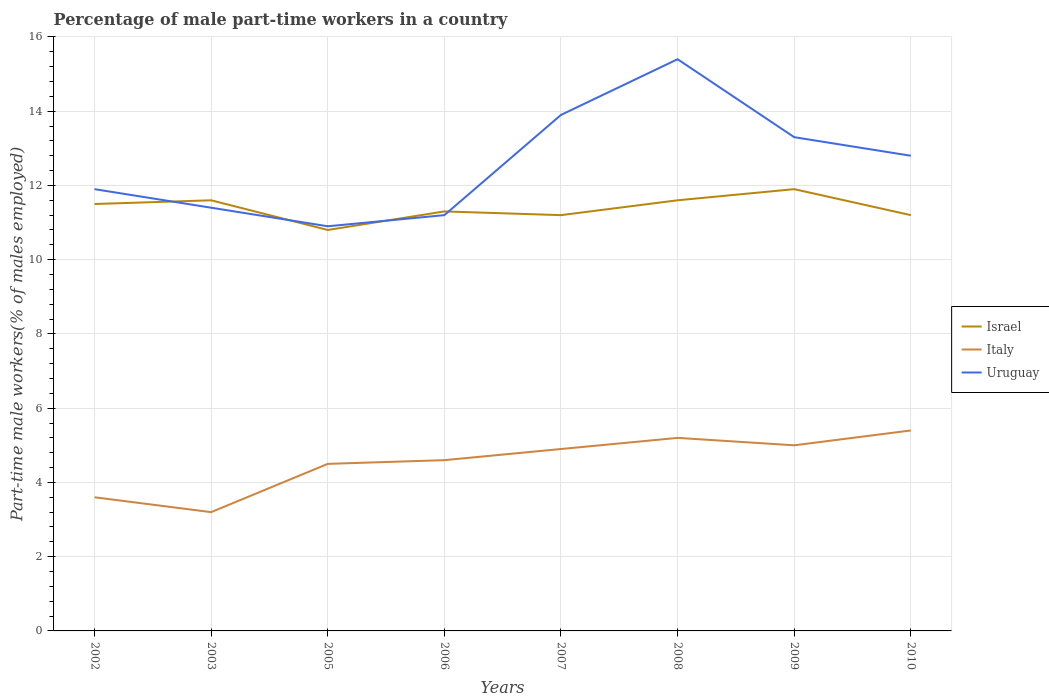Is the number of lines equal to the number of legend labels?
Keep it short and to the point. Yes. Across all years, what is the maximum percentage of male part-time workers in Uruguay?
Your response must be concise. 10.9. In which year was the percentage of male part-time workers in Italy maximum?
Your answer should be very brief. 2003. What is the difference between the highest and the second highest percentage of male part-time workers in Italy?
Your answer should be very brief. 2.2. Is the percentage of male part-time workers in Italy strictly greater than the percentage of male part-time workers in Israel over the years?
Provide a short and direct response. Yes. How many lines are there?
Provide a succinct answer. 3. How many years are there in the graph?
Offer a terse response. 8. What is the difference between two consecutive major ticks on the Y-axis?
Your answer should be compact. 2. Are the values on the major ticks of Y-axis written in scientific E-notation?
Your response must be concise. No. Does the graph contain grids?
Your answer should be very brief. Yes. How are the legend labels stacked?
Offer a very short reply. Vertical. What is the title of the graph?
Keep it short and to the point. Percentage of male part-time workers in a country. Does "Zimbabwe" appear as one of the legend labels in the graph?
Make the answer very short. No. What is the label or title of the Y-axis?
Keep it short and to the point. Part-time male workers(% of males employed). What is the Part-time male workers(% of males employed) of Israel in 2002?
Make the answer very short. 11.5. What is the Part-time male workers(% of males employed) in Italy in 2002?
Provide a succinct answer. 3.6. What is the Part-time male workers(% of males employed) of Uruguay in 2002?
Provide a short and direct response. 11.9. What is the Part-time male workers(% of males employed) of Israel in 2003?
Provide a succinct answer. 11.6. What is the Part-time male workers(% of males employed) in Italy in 2003?
Offer a terse response. 3.2. What is the Part-time male workers(% of males employed) of Uruguay in 2003?
Your answer should be compact. 11.4. What is the Part-time male workers(% of males employed) of Israel in 2005?
Your answer should be very brief. 10.8. What is the Part-time male workers(% of males employed) in Italy in 2005?
Give a very brief answer. 4.5. What is the Part-time male workers(% of males employed) in Uruguay in 2005?
Offer a terse response. 10.9. What is the Part-time male workers(% of males employed) of Israel in 2006?
Your response must be concise. 11.3. What is the Part-time male workers(% of males employed) of Italy in 2006?
Offer a terse response. 4.6. What is the Part-time male workers(% of males employed) in Uruguay in 2006?
Your response must be concise. 11.2. What is the Part-time male workers(% of males employed) in Israel in 2007?
Give a very brief answer. 11.2. What is the Part-time male workers(% of males employed) of Italy in 2007?
Offer a terse response. 4.9. What is the Part-time male workers(% of males employed) in Uruguay in 2007?
Your answer should be compact. 13.9. What is the Part-time male workers(% of males employed) of Israel in 2008?
Your response must be concise. 11.6. What is the Part-time male workers(% of males employed) in Italy in 2008?
Keep it short and to the point. 5.2. What is the Part-time male workers(% of males employed) in Uruguay in 2008?
Keep it short and to the point. 15.4. What is the Part-time male workers(% of males employed) of Israel in 2009?
Offer a terse response. 11.9. What is the Part-time male workers(% of males employed) in Uruguay in 2009?
Offer a terse response. 13.3. What is the Part-time male workers(% of males employed) in Israel in 2010?
Your answer should be compact. 11.2. What is the Part-time male workers(% of males employed) in Italy in 2010?
Make the answer very short. 5.4. What is the Part-time male workers(% of males employed) in Uruguay in 2010?
Offer a terse response. 12.8. Across all years, what is the maximum Part-time male workers(% of males employed) of Israel?
Offer a very short reply. 11.9. Across all years, what is the maximum Part-time male workers(% of males employed) of Italy?
Keep it short and to the point. 5.4. Across all years, what is the maximum Part-time male workers(% of males employed) of Uruguay?
Your answer should be compact. 15.4. Across all years, what is the minimum Part-time male workers(% of males employed) in Israel?
Offer a very short reply. 10.8. Across all years, what is the minimum Part-time male workers(% of males employed) of Italy?
Give a very brief answer. 3.2. Across all years, what is the minimum Part-time male workers(% of males employed) of Uruguay?
Provide a succinct answer. 10.9. What is the total Part-time male workers(% of males employed) in Israel in the graph?
Give a very brief answer. 91.1. What is the total Part-time male workers(% of males employed) of Italy in the graph?
Offer a terse response. 36.4. What is the total Part-time male workers(% of males employed) of Uruguay in the graph?
Your answer should be very brief. 100.8. What is the difference between the Part-time male workers(% of males employed) in Israel in 2002 and that in 2003?
Keep it short and to the point. -0.1. What is the difference between the Part-time male workers(% of males employed) in Italy in 2002 and that in 2003?
Keep it short and to the point. 0.4. What is the difference between the Part-time male workers(% of males employed) in Uruguay in 2002 and that in 2003?
Your answer should be very brief. 0.5. What is the difference between the Part-time male workers(% of males employed) of Israel in 2002 and that in 2005?
Keep it short and to the point. 0.7. What is the difference between the Part-time male workers(% of males employed) of Uruguay in 2002 and that in 2005?
Offer a terse response. 1. What is the difference between the Part-time male workers(% of males employed) in Uruguay in 2002 and that in 2006?
Offer a very short reply. 0.7. What is the difference between the Part-time male workers(% of males employed) in Italy in 2002 and that in 2007?
Keep it short and to the point. -1.3. What is the difference between the Part-time male workers(% of males employed) of Uruguay in 2002 and that in 2008?
Make the answer very short. -3.5. What is the difference between the Part-time male workers(% of males employed) in Israel in 2002 and that in 2009?
Your response must be concise. -0.4. What is the difference between the Part-time male workers(% of males employed) in Uruguay in 2002 and that in 2009?
Your answer should be very brief. -1.4. What is the difference between the Part-time male workers(% of males employed) in Israel in 2003 and that in 2005?
Ensure brevity in your answer.  0.8. What is the difference between the Part-time male workers(% of males employed) in Uruguay in 2003 and that in 2005?
Your response must be concise. 0.5. What is the difference between the Part-time male workers(% of males employed) of Israel in 2003 and that in 2006?
Ensure brevity in your answer.  0.3. What is the difference between the Part-time male workers(% of males employed) in Italy in 2003 and that in 2006?
Your response must be concise. -1.4. What is the difference between the Part-time male workers(% of males employed) in Uruguay in 2003 and that in 2006?
Make the answer very short. 0.2. What is the difference between the Part-time male workers(% of males employed) of Italy in 2003 and that in 2009?
Provide a short and direct response. -1.8. What is the difference between the Part-time male workers(% of males employed) of Italy in 2003 and that in 2010?
Keep it short and to the point. -2.2. What is the difference between the Part-time male workers(% of males employed) of Israel in 2005 and that in 2006?
Ensure brevity in your answer.  -0.5. What is the difference between the Part-time male workers(% of males employed) of Israel in 2005 and that in 2007?
Offer a terse response. -0.4. What is the difference between the Part-time male workers(% of males employed) in Italy in 2005 and that in 2008?
Provide a succinct answer. -0.7. What is the difference between the Part-time male workers(% of males employed) in Israel in 2005 and that in 2009?
Give a very brief answer. -1.1. What is the difference between the Part-time male workers(% of males employed) of Italy in 2005 and that in 2009?
Ensure brevity in your answer.  -0.5. What is the difference between the Part-time male workers(% of males employed) in Israel in 2005 and that in 2010?
Provide a short and direct response. -0.4. What is the difference between the Part-time male workers(% of males employed) of Italy in 2005 and that in 2010?
Provide a succinct answer. -0.9. What is the difference between the Part-time male workers(% of males employed) in Uruguay in 2005 and that in 2010?
Offer a terse response. -1.9. What is the difference between the Part-time male workers(% of males employed) in Israel in 2006 and that in 2007?
Give a very brief answer. 0.1. What is the difference between the Part-time male workers(% of males employed) of Israel in 2006 and that in 2008?
Your answer should be very brief. -0.3. What is the difference between the Part-time male workers(% of males employed) in Uruguay in 2006 and that in 2009?
Keep it short and to the point. -2.1. What is the difference between the Part-time male workers(% of males employed) in Israel in 2006 and that in 2010?
Offer a very short reply. 0.1. What is the difference between the Part-time male workers(% of males employed) of Italy in 2007 and that in 2008?
Provide a succinct answer. -0.3. What is the difference between the Part-time male workers(% of males employed) of Israel in 2007 and that in 2009?
Your answer should be very brief. -0.7. What is the difference between the Part-time male workers(% of males employed) of Uruguay in 2007 and that in 2010?
Keep it short and to the point. 1.1. What is the difference between the Part-time male workers(% of males employed) in Israel in 2008 and that in 2009?
Your answer should be very brief. -0.3. What is the difference between the Part-time male workers(% of males employed) in Italy in 2008 and that in 2009?
Your answer should be compact. 0.2. What is the difference between the Part-time male workers(% of males employed) in Israel in 2008 and that in 2010?
Offer a very short reply. 0.4. What is the difference between the Part-time male workers(% of males employed) in Uruguay in 2008 and that in 2010?
Keep it short and to the point. 2.6. What is the difference between the Part-time male workers(% of males employed) in Israel in 2009 and that in 2010?
Your answer should be very brief. 0.7. What is the difference between the Part-time male workers(% of males employed) in Italy in 2009 and that in 2010?
Your answer should be very brief. -0.4. What is the difference between the Part-time male workers(% of males employed) in Israel in 2002 and the Part-time male workers(% of males employed) in Uruguay in 2003?
Ensure brevity in your answer.  0.1. What is the difference between the Part-time male workers(% of males employed) of Italy in 2002 and the Part-time male workers(% of males employed) of Uruguay in 2003?
Make the answer very short. -7.8. What is the difference between the Part-time male workers(% of males employed) in Israel in 2002 and the Part-time male workers(% of males employed) in Italy in 2005?
Provide a short and direct response. 7. What is the difference between the Part-time male workers(% of males employed) of Israel in 2002 and the Part-time male workers(% of males employed) of Italy in 2006?
Ensure brevity in your answer.  6.9. What is the difference between the Part-time male workers(% of males employed) in Israel in 2002 and the Part-time male workers(% of males employed) in Uruguay in 2006?
Offer a terse response. 0.3. What is the difference between the Part-time male workers(% of males employed) in Italy in 2002 and the Part-time male workers(% of males employed) in Uruguay in 2006?
Offer a very short reply. -7.6. What is the difference between the Part-time male workers(% of males employed) of Israel in 2002 and the Part-time male workers(% of males employed) of Italy in 2007?
Provide a short and direct response. 6.6. What is the difference between the Part-time male workers(% of males employed) of Israel in 2002 and the Part-time male workers(% of males employed) of Uruguay in 2007?
Provide a short and direct response. -2.4. What is the difference between the Part-time male workers(% of males employed) of Italy in 2002 and the Part-time male workers(% of males employed) of Uruguay in 2007?
Offer a terse response. -10.3. What is the difference between the Part-time male workers(% of males employed) in Israel in 2002 and the Part-time male workers(% of males employed) in Italy in 2008?
Your answer should be very brief. 6.3. What is the difference between the Part-time male workers(% of males employed) of Israel in 2002 and the Part-time male workers(% of males employed) of Uruguay in 2008?
Provide a succinct answer. -3.9. What is the difference between the Part-time male workers(% of males employed) in Italy in 2002 and the Part-time male workers(% of males employed) in Uruguay in 2008?
Your answer should be compact. -11.8. What is the difference between the Part-time male workers(% of males employed) of Italy in 2002 and the Part-time male workers(% of males employed) of Uruguay in 2009?
Offer a very short reply. -9.7. What is the difference between the Part-time male workers(% of males employed) of Italy in 2002 and the Part-time male workers(% of males employed) of Uruguay in 2010?
Offer a very short reply. -9.2. What is the difference between the Part-time male workers(% of males employed) in Israel in 2003 and the Part-time male workers(% of males employed) in Uruguay in 2006?
Your response must be concise. 0.4. What is the difference between the Part-time male workers(% of males employed) in Italy in 2003 and the Part-time male workers(% of males employed) in Uruguay in 2006?
Offer a terse response. -8. What is the difference between the Part-time male workers(% of males employed) in Israel in 2003 and the Part-time male workers(% of males employed) in Uruguay in 2007?
Offer a terse response. -2.3. What is the difference between the Part-time male workers(% of males employed) in Italy in 2003 and the Part-time male workers(% of males employed) in Uruguay in 2007?
Make the answer very short. -10.7. What is the difference between the Part-time male workers(% of males employed) in Israel in 2003 and the Part-time male workers(% of males employed) in Italy in 2008?
Provide a succinct answer. 6.4. What is the difference between the Part-time male workers(% of males employed) of Israel in 2003 and the Part-time male workers(% of males employed) of Italy in 2009?
Provide a succinct answer. 6.6. What is the difference between the Part-time male workers(% of males employed) in Israel in 2003 and the Part-time male workers(% of males employed) in Uruguay in 2009?
Make the answer very short. -1.7. What is the difference between the Part-time male workers(% of males employed) of Israel in 2003 and the Part-time male workers(% of males employed) of Italy in 2010?
Your answer should be very brief. 6.2. What is the difference between the Part-time male workers(% of males employed) in Israel in 2003 and the Part-time male workers(% of males employed) in Uruguay in 2010?
Your answer should be very brief. -1.2. What is the difference between the Part-time male workers(% of males employed) of Israel in 2005 and the Part-time male workers(% of males employed) of Italy in 2006?
Offer a very short reply. 6.2. What is the difference between the Part-time male workers(% of males employed) in Israel in 2005 and the Part-time male workers(% of males employed) in Uruguay in 2006?
Provide a short and direct response. -0.4. What is the difference between the Part-time male workers(% of males employed) in Italy in 2005 and the Part-time male workers(% of males employed) in Uruguay in 2006?
Ensure brevity in your answer.  -6.7. What is the difference between the Part-time male workers(% of males employed) in Israel in 2005 and the Part-time male workers(% of males employed) in Italy in 2008?
Your response must be concise. 5.6. What is the difference between the Part-time male workers(% of males employed) of Italy in 2005 and the Part-time male workers(% of males employed) of Uruguay in 2008?
Provide a short and direct response. -10.9. What is the difference between the Part-time male workers(% of males employed) of Israel in 2005 and the Part-time male workers(% of males employed) of Italy in 2009?
Your answer should be compact. 5.8. What is the difference between the Part-time male workers(% of males employed) in Italy in 2005 and the Part-time male workers(% of males employed) in Uruguay in 2009?
Provide a succinct answer. -8.8. What is the difference between the Part-time male workers(% of males employed) of Israel in 2005 and the Part-time male workers(% of males employed) of Italy in 2010?
Make the answer very short. 5.4. What is the difference between the Part-time male workers(% of males employed) in Israel in 2005 and the Part-time male workers(% of males employed) in Uruguay in 2010?
Offer a very short reply. -2. What is the difference between the Part-time male workers(% of males employed) of Italy in 2005 and the Part-time male workers(% of males employed) of Uruguay in 2010?
Provide a succinct answer. -8.3. What is the difference between the Part-time male workers(% of males employed) in Israel in 2006 and the Part-time male workers(% of males employed) in Italy in 2008?
Ensure brevity in your answer.  6.1. What is the difference between the Part-time male workers(% of males employed) of Israel in 2006 and the Part-time male workers(% of males employed) of Uruguay in 2008?
Offer a very short reply. -4.1. What is the difference between the Part-time male workers(% of males employed) of Italy in 2006 and the Part-time male workers(% of males employed) of Uruguay in 2009?
Offer a terse response. -8.7. What is the difference between the Part-time male workers(% of males employed) in Israel in 2007 and the Part-time male workers(% of males employed) in Italy in 2008?
Give a very brief answer. 6. What is the difference between the Part-time male workers(% of males employed) of Israel in 2007 and the Part-time male workers(% of males employed) of Italy in 2009?
Provide a short and direct response. 6.2. What is the difference between the Part-time male workers(% of males employed) in Israel in 2007 and the Part-time male workers(% of males employed) in Uruguay in 2009?
Offer a very short reply. -2.1. What is the difference between the Part-time male workers(% of males employed) in Israel in 2007 and the Part-time male workers(% of males employed) in Italy in 2010?
Keep it short and to the point. 5.8. What is the difference between the Part-time male workers(% of males employed) of Israel in 2008 and the Part-time male workers(% of males employed) of Uruguay in 2009?
Provide a succinct answer. -1.7. What is the difference between the Part-time male workers(% of males employed) of Israel in 2008 and the Part-time male workers(% of males employed) of Italy in 2010?
Make the answer very short. 6.2. What is the difference between the Part-time male workers(% of males employed) in Israel in 2008 and the Part-time male workers(% of males employed) in Uruguay in 2010?
Ensure brevity in your answer.  -1.2. What is the difference between the Part-time male workers(% of males employed) of Italy in 2008 and the Part-time male workers(% of males employed) of Uruguay in 2010?
Make the answer very short. -7.6. What is the difference between the Part-time male workers(% of males employed) of Israel in 2009 and the Part-time male workers(% of males employed) of Italy in 2010?
Keep it short and to the point. 6.5. What is the difference between the Part-time male workers(% of males employed) of Israel in 2009 and the Part-time male workers(% of males employed) of Uruguay in 2010?
Offer a very short reply. -0.9. What is the average Part-time male workers(% of males employed) of Israel per year?
Keep it short and to the point. 11.39. What is the average Part-time male workers(% of males employed) of Italy per year?
Make the answer very short. 4.55. What is the average Part-time male workers(% of males employed) of Uruguay per year?
Offer a terse response. 12.6. In the year 2002, what is the difference between the Part-time male workers(% of males employed) in Italy and Part-time male workers(% of males employed) in Uruguay?
Give a very brief answer. -8.3. In the year 2005, what is the difference between the Part-time male workers(% of males employed) of Italy and Part-time male workers(% of males employed) of Uruguay?
Your answer should be very brief. -6.4. In the year 2006, what is the difference between the Part-time male workers(% of males employed) in Israel and Part-time male workers(% of males employed) in Italy?
Your answer should be very brief. 6.7. In the year 2006, what is the difference between the Part-time male workers(% of males employed) in Israel and Part-time male workers(% of males employed) in Uruguay?
Ensure brevity in your answer.  0.1. In the year 2006, what is the difference between the Part-time male workers(% of males employed) in Italy and Part-time male workers(% of males employed) in Uruguay?
Ensure brevity in your answer.  -6.6. In the year 2007, what is the difference between the Part-time male workers(% of males employed) in Israel and Part-time male workers(% of males employed) in Italy?
Provide a succinct answer. 6.3. In the year 2008, what is the difference between the Part-time male workers(% of males employed) of Italy and Part-time male workers(% of males employed) of Uruguay?
Make the answer very short. -10.2. In the year 2009, what is the difference between the Part-time male workers(% of males employed) of Israel and Part-time male workers(% of males employed) of Italy?
Provide a short and direct response. 6.9. In the year 2009, what is the difference between the Part-time male workers(% of males employed) in Italy and Part-time male workers(% of males employed) in Uruguay?
Your response must be concise. -8.3. In the year 2010, what is the difference between the Part-time male workers(% of males employed) of Israel and Part-time male workers(% of males employed) of Italy?
Your answer should be very brief. 5.8. In the year 2010, what is the difference between the Part-time male workers(% of males employed) of Italy and Part-time male workers(% of males employed) of Uruguay?
Your answer should be very brief. -7.4. What is the ratio of the Part-time male workers(% of males employed) of Italy in 2002 to that in 2003?
Make the answer very short. 1.12. What is the ratio of the Part-time male workers(% of males employed) in Uruguay in 2002 to that in 2003?
Your answer should be compact. 1.04. What is the ratio of the Part-time male workers(% of males employed) in Israel in 2002 to that in 2005?
Offer a terse response. 1.06. What is the ratio of the Part-time male workers(% of males employed) in Italy in 2002 to that in 2005?
Make the answer very short. 0.8. What is the ratio of the Part-time male workers(% of males employed) in Uruguay in 2002 to that in 2005?
Offer a very short reply. 1.09. What is the ratio of the Part-time male workers(% of males employed) in Israel in 2002 to that in 2006?
Provide a short and direct response. 1.02. What is the ratio of the Part-time male workers(% of males employed) in Italy in 2002 to that in 2006?
Offer a terse response. 0.78. What is the ratio of the Part-time male workers(% of males employed) in Israel in 2002 to that in 2007?
Make the answer very short. 1.03. What is the ratio of the Part-time male workers(% of males employed) of Italy in 2002 to that in 2007?
Keep it short and to the point. 0.73. What is the ratio of the Part-time male workers(% of males employed) of Uruguay in 2002 to that in 2007?
Your response must be concise. 0.86. What is the ratio of the Part-time male workers(% of males employed) of Israel in 2002 to that in 2008?
Offer a terse response. 0.99. What is the ratio of the Part-time male workers(% of males employed) of Italy in 2002 to that in 2008?
Make the answer very short. 0.69. What is the ratio of the Part-time male workers(% of males employed) of Uruguay in 2002 to that in 2008?
Make the answer very short. 0.77. What is the ratio of the Part-time male workers(% of males employed) of Israel in 2002 to that in 2009?
Offer a very short reply. 0.97. What is the ratio of the Part-time male workers(% of males employed) of Italy in 2002 to that in 2009?
Make the answer very short. 0.72. What is the ratio of the Part-time male workers(% of males employed) of Uruguay in 2002 to that in 2009?
Provide a short and direct response. 0.89. What is the ratio of the Part-time male workers(% of males employed) in Israel in 2002 to that in 2010?
Provide a succinct answer. 1.03. What is the ratio of the Part-time male workers(% of males employed) of Uruguay in 2002 to that in 2010?
Your response must be concise. 0.93. What is the ratio of the Part-time male workers(% of males employed) of Israel in 2003 to that in 2005?
Your answer should be compact. 1.07. What is the ratio of the Part-time male workers(% of males employed) in Italy in 2003 to that in 2005?
Make the answer very short. 0.71. What is the ratio of the Part-time male workers(% of males employed) of Uruguay in 2003 to that in 2005?
Provide a short and direct response. 1.05. What is the ratio of the Part-time male workers(% of males employed) of Israel in 2003 to that in 2006?
Your answer should be compact. 1.03. What is the ratio of the Part-time male workers(% of males employed) in Italy in 2003 to that in 2006?
Offer a very short reply. 0.7. What is the ratio of the Part-time male workers(% of males employed) in Uruguay in 2003 to that in 2006?
Keep it short and to the point. 1.02. What is the ratio of the Part-time male workers(% of males employed) of Israel in 2003 to that in 2007?
Your response must be concise. 1.04. What is the ratio of the Part-time male workers(% of males employed) of Italy in 2003 to that in 2007?
Your answer should be compact. 0.65. What is the ratio of the Part-time male workers(% of males employed) of Uruguay in 2003 to that in 2007?
Make the answer very short. 0.82. What is the ratio of the Part-time male workers(% of males employed) of Italy in 2003 to that in 2008?
Your answer should be compact. 0.62. What is the ratio of the Part-time male workers(% of males employed) in Uruguay in 2003 to that in 2008?
Ensure brevity in your answer.  0.74. What is the ratio of the Part-time male workers(% of males employed) in Israel in 2003 to that in 2009?
Your response must be concise. 0.97. What is the ratio of the Part-time male workers(% of males employed) in Italy in 2003 to that in 2009?
Offer a very short reply. 0.64. What is the ratio of the Part-time male workers(% of males employed) in Israel in 2003 to that in 2010?
Provide a short and direct response. 1.04. What is the ratio of the Part-time male workers(% of males employed) in Italy in 2003 to that in 2010?
Ensure brevity in your answer.  0.59. What is the ratio of the Part-time male workers(% of males employed) in Uruguay in 2003 to that in 2010?
Your response must be concise. 0.89. What is the ratio of the Part-time male workers(% of males employed) of Israel in 2005 to that in 2006?
Offer a terse response. 0.96. What is the ratio of the Part-time male workers(% of males employed) in Italy in 2005 to that in 2006?
Provide a succinct answer. 0.98. What is the ratio of the Part-time male workers(% of males employed) of Uruguay in 2005 to that in 2006?
Your answer should be very brief. 0.97. What is the ratio of the Part-time male workers(% of males employed) of Italy in 2005 to that in 2007?
Give a very brief answer. 0.92. What is the ratio of the Part-time male workers(% of males employed) of Uruguay in 2005 to that in 2007?
Offer a terse response. 0.78. What is the ratio of the Part-time male workers(% of males employed) of Italy in 2005 to that in 2008?
Make the answer very short. 0.87. What is the ratio of the Part-time male workers(% of males employed) of Uruguay in 2005 to that in 2008?
Your answer should be compact. 0.71. What is the ratio of the Part-time male workers(% of males employed) of Israel in 2005 to that in 2009?
Keep it short and to the point. 0.91. What is the ratio of the Part-time male workers(% of males employed) in Uruguay in 2005 to that in 2009?
Give a very brief answer. 0.82. What is the ratio of the Part-time male workers(% of males employed) in Israel in 2005 to that in 2010?
Keep it short and to the point. 0.96. What is the ratio of the Part-time male workers(% of males employed) in Italy in 2005 to that in 2010?
Ensure brevity in your answer.  0.83. What is the ratio of the Part-time male workers(% of males employed) in Uruguay in 2005 to that in 2010?
Your answer should be compact. 0.85. What is the ratio of the Part-time male workers(% of males employed) of Israel in 2006 to that in 2007?
Your answer should be compact. 1.01. What is the ratio of the Part-time male workers(% of males employed) in Italy in 2006 to that in 2007?
Ensure brevity in your answer.  0.94. What is the ratio of the Part-time male workers(% of males employed) in Uruguay in 2006 to that in 2007?
Offer a terse response. 0.81. What is the ratio of the Part-time male workers(% of males employed) of Israel in 2006 to that in 2008?
Provide a succinct answer. 0.97. What is the ratio of the Part-time male workers(% of males employed) of Italy in 2006 to that in 2008?
Give a very brief answer. 0.88. What is the ratio of the Part-time male workers(% of males employed) in Uruguay in 2006 to that in 2008?
Make the answer very short. 0.73. What is the ratio of the Part-time male workers(% of males employed) in Israel in 2006 to that in 2009?
Provide a short and direct response. 0.95. What is the ratio of the Part-time male workers(% of males employed) of Uruguay in 2006 to that in 2009?
Provide a short and direct response. 0.84. What is the ratio of the Part-time male workers(% of males employed) in Israel in 2006 to that in 2010?
Your answer should be very brief. 1.01. What is the ratio of the Part-time male workers(% of males employed) in Italy in 2006 to that in 2010?
Your answer should be compact. 0.85. What is the ratio of the Part-time male workers(% of males employed) of Uruguay in 2006 to that in 2010?
Provide a short and direct response. 0.88. What is the ratio of the Part-time male workers(% of males employed) in Israel in 2007 to that in 2008?
Offer a very short reply. 0.97. What is the ratio of the Part-time male workers(% of males employed) in Italy in 2007 to that in 2008?
Your answer should be compact. 0.94. What is the ratio of the Part-time male workers(% of males employed) in Uruguay in 2007 to that in 2008?
Provide a succinct answer. 0.9. What is the ratio of the Part-time male workers(% of males employed) of Uruguay in 2007 to that in 2009?
Provide a short and direct response. 1.05. What is the ratio of the Part-time male workers(% of males employed) of Israel in 2007 to that in 2010?
Offer a terse response. 1. What is the ratio of the Part-time male workers(% of males employed) of Italy in 2007 to that in 2010?
Offer a terse response. 0.91. What is the ratio of the Part-time male workers(% of males employed) of Uruguay in 2007 to that in 2010?
Make the answer very short. 1.09. What is the ratio of the Part-time male workers(% of males employed) in Israel in 2008 to that in 2009?
Provide a succinct answer. 0.97. What is the ratio of the Part-time male workers(% of males employed) of Italy in 2008 to that in 2009?
Your answer should be very brief. 1.04. What is the ratio of the Part-time male workers(% of males employed) of Uruguay in 2008 to that in 2009?
Keep it short and to the point. 1.16. What is the ratio of the Part-time male workers(% of males employed) of Israel in 2008 to that in 2010?
Ensure brevity in your answer.  1.04. What is the ratio of the Part-time male workers(% of males employed) of Italy in 2008 to that in 2010?
Your answer should be compact. 0.96. What is the ratio of the Part-time male workers(% of males employed) in Uruguay in 2008 to that in 2010?
Your answer should be very brief. 1.2. What is the ratio of the Part-time male workers(% of males employed) of Israel in 2009 to that in 2010?
Provide a short and direct response. 1.06. What is the ratio of the Part-time male workers(% of males employed) of Italy in 2009 to that in 2010?
Ensure brevity in your answer.  0.93. What is the ratio of the Part-time male workers(% of males employed) in Uruguay in 2009 to that in 2010?
Your answer should be very brief. 1.04. What is the difference between the highest and the second highest Part-time male workers(% of males employed) in Italy?
Your answer should be very brief. 0.2. What is the difference between the highest and the lowest Part-time male workers(% of males employed) in Israel?
Your response must be concise. 1.1. What is the difference between the highest and the lowest Part-time male workers(% of males employed) of Italy?
Your answer should be very brief. 2.2. What is the difference between the highest and the lowest Part-time male workers(% of males employed) in Uruguay?
Ensure brevity in your answer.  4.5. 